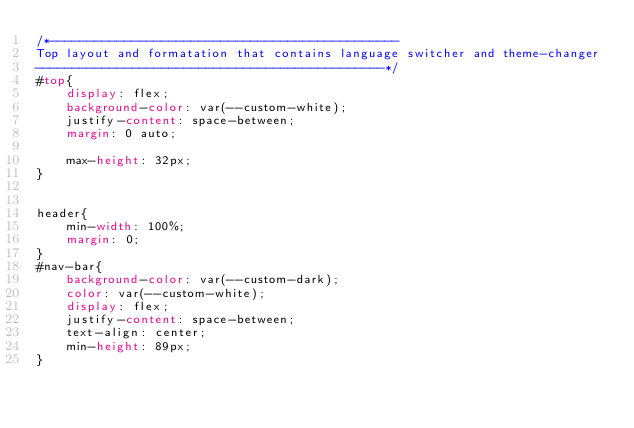<code> <loc_0><loc_0><loc_500><loc_500><_CSS_>/*-----------------------------------------------
Top layout and formatation that contains language switcher and theme-changer
-----------------------------------------------*/
#top{
    display: flex;
    background-color: var(--custom-white);
    justify-content: space-between;
    margin: 0 auto;
    
    max-height: 32px;
}


header{
    min-width: 100%;
    margin: 0;
}
#nav-bar{
    background-color: var(--custom-dark);
    color: var(--custom-white);
    display: flex;
    justify-content: space-between;
    text-align: center;
    min-height: 89px;
}</code> 